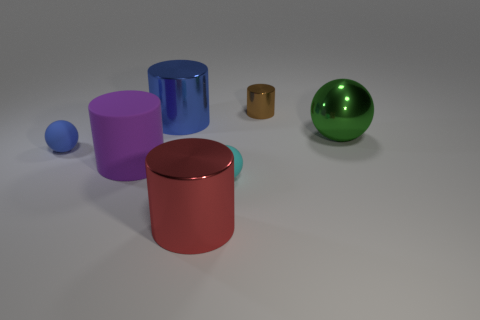How many objects are on the ground, and can you describe their shapes? There are five objects on the ground, consisting of two spheres, one large and one small, and three cylinders of various sizes and colors. 